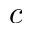Convert formula to latex. <formula><loc_0><loc_0><loc_500><loc_500>c</formula> 